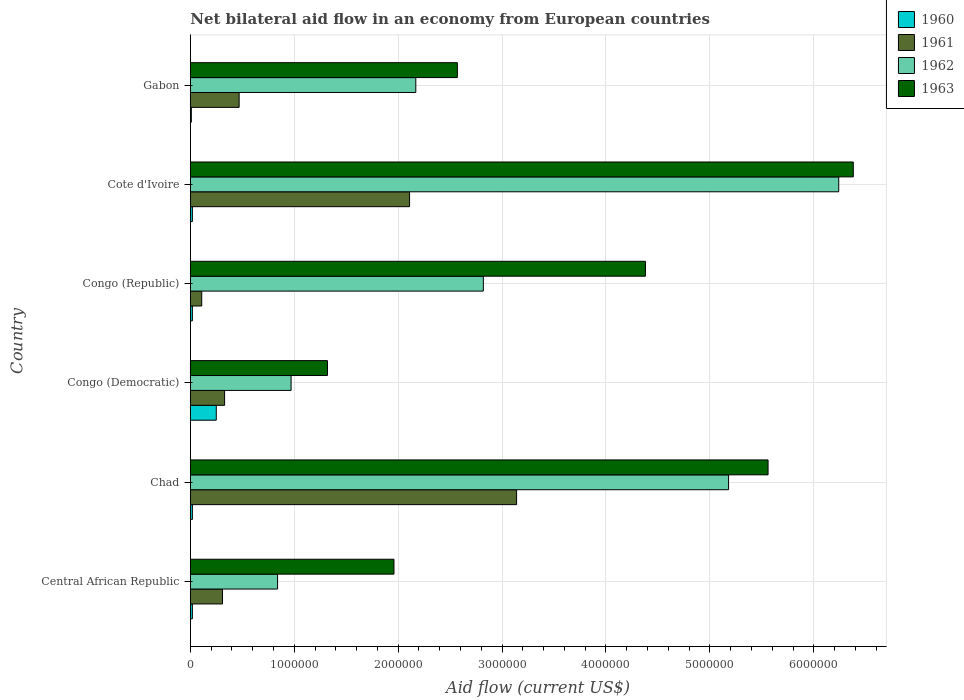How many bars are there on the 4th tick from the top?
Provide a succinct answer. 4. What is the label of the 1st group of bars from the top?
Provide a succinct answer. Gabon. In how many cases, is the number of bars for a given country not equal to the number of legend labels?
Keep it short and to the point. 0. What is the net bilateral aid flow in 1961 in Chad?
Your response must be concise. 3.14e+06. Across all countries, what is the maximum net bilateral aid flow in 1963?
Offer a terse response. 6.38e+06. Across all countries, what is the minimum net bilateral aid flow in 1963?
Provide a short and direct response. 1.32e+06. In which country was the net bilateral aid flow in 1960 maximum?
Your answer should be very brief. Congo (Democratic). In which country was the net bilateral aid flow in 1963 minimum?
Offer a terse response. Congo (Democratic). What is the total net bilateral aid flow in 1962 in the graph?
Provide a succinct answer. 1.82e+07. What is the difference between the net bilateral aid flow in 1961 in Chad and that in Congo (Republic)?
Offer a very short reply. 3.03e+06. What is the difference between the net bilateral aid flow in 1963 in Gabon and the net bilateral aid flow in 1960 in Cote d'Ivoire?
Your response must be concise. 2.55e+06. What is the average net bilateral aid flow in 1963 per country?
Offer a very short reply. 3.70e+06. What is the difference between the net bilateral aid flow in 1960 and net bilateral aid flow in 1962 in Cote d'Ivoire?
Give a very brief answer. -6.22e+06. In how many countries, is the net bilateral aid flow in 1961 greater than 200000 US$?
Your answer should be very brief. 5. What is the ratio of the net bilateral aid flow in 1963 in Central African Republic to that in Chad?
Offer a very short reply. 0.35. What is the difference between the highest and the second highest net bilateral aid flow in 1960?
Offer a very short reply. 2.30e+05. In how many countries, is the net bilateral aid flow in 1962 greater than the average net bilateral aid flow in 1962 taken over all countries?
Offer a very short reply. 2. Is the sum of the net bilateral aid flow in 1963 in Chad and Congo (Republic) greater than the maximum net bilateral aid flow in 1962 across all countries?
Offer a terse response. Yes. What does the 2nd bar from the top in Chad represents?
Keep it short and to the point. 1962. Is it the case that in every country, the sum of the net bilateral aid flow in 1963 and net bilateral aid flow in 1960 is greater than the net bilateral aid flow in 1961?
Offer a terse response. Yes. How many bars are there?
Keep it short and to the point. 24. Are all the bars in the graph horizontal?
Provide a succinct answer. Yes. How many countries are there in the graph?
Keep it short and to the point. 6. What is the difference between two consecutive major ticks on the X-axis?
Keep it short and to the point. 1.00e+06. Are the values on the major ticks of X-axis written in scientific E-notation?
Offer a very short reply. No. Where does the legend appear in the graph?
Make the answer very short. Top right. What is the title of the graph?
Your answer should be compact. Net bilateral aid flow in an economy from European countries. What is the label or title of the Y-axis?
Offer a terse response. Country. What is the Aid flow (current US$) of 1960 in Central African Republic?
Keep it short and to the point. 2.00e+04. What is the Aid flow (current US$) in 1961 in Central African Republic?
Provide a succinct answer. 3.10e+05. What is the Aid flow (current US$) of 1962 in Central African Republic?
Your answer should be very brief. 8.40e+05. What is the Aid flow (current US$) of 1963 in Central African Republic?
Make the answer very short. 1.96e+06. What is the Aid flow (current US$) in 1961 in Chad?
Your answer should be compact. 3.14e+06. What is the Aid flow (current US$) of 1962 in Chad?
Provide a succinct answer. 5.18e+06. What is the Aid flow (current US$) of 1963 in Chad?
Give a very brief answer. 5.56e+06. What is the Aid flow (current US$) in 1961 in Congo (Democratic)?
Give a very brief answer. 3.30e+05. What is the Aid flow (current US$) of 1962 in Congo (Democratic)?
Give a very brief answer. 9.70e+05. What is the Aid flow (current US$) of 1963 in Congo (Democratic)?
Provide a short and direct response. 1.32e+06. What is the Aid flow (current US$) in 1961 in Congo (Republic)?
Offer a terse response. 1.10e+05. What is the Aid flow (current US$) of 1962 in Congo (Republic)?
Provide a short and direct response. 2.82e+06. What is the Aid flow (current US$) of 1963 in Congo (Republic)?
Provide a succinct answer. 4.38e+06. What is the Aid flow (current US$) in 1961 in Cote d'Ivoire?
Provide a short and direct response. 2.11e+06. What is the Aid flow (current US$) of 1962 in Cote d'Ivoire?
Give a very brief answer. 6.24e+06. What is the Aid flow (current US$) of 1963 in Cote d'Ivoire?
Keep it short and to the point. 6.38e+06. What is the Aid flow (current US$) in 1960 in Gabon?
Your answer should be very brief. 10000. What is the Aid flow (current US$) of 1961 in Gabon?
Offer a terse response. 4.70e+05. What is the Aid flow (current US$) of 1962 in Gabon?
Offer a very short reply. 2.17e+06. What is the Aid flow (current US$) of 1963 in Gabon?
Offer a very short reply. 2.57e+06. Across all countries, what is the maximum Aid flow (current US$) in 1961?
Your answer should be very brief. 3.14e+06. Across all countries, what is the maximum Aid flow (current US$) in 1962?
Your response must be concise. 6.24e+06. Across all countries, what is the maximum Aid flow (current US$) of 1963?
Ensure brevity in your answer.  6.38e+06. Across all countries, what is the minimum Aid flow (current US$) of 1962?
Keep it short and to the point. 8.40e+05. Across all countries, what is the minimum Aid flow (current US$) in 1963?
Offer a terse response. 1.32e+06. What is the total Aid flow (current US$) in 1960 in the graph?
Give a very brief answer. 3.40e+05. What is the total Aid flow (current US$) of 1961 in the graph?
Your answer should be compact. 6.47e+06. What is the total Aid flow (current US$) of 1962 in the graph?
Make the answer very short. 1.82e+07. What is the total Aid flow (current US$) in 1963 in the graph?
Keep it short and to the point. 2.22e+07. What is the difference between the Aid flow (current US$) of 1961 in Central African Republic and that in Chad?
Offer a terse response. -2.83e+06. What is the difference between the Aid flow (current US$) in 1962 in Central African Republic and that in Chad?
Offer a very short reply. -4.34e+06. What is the difference between the Aid flow (current US$) in 1963 in Central African Republic and that in Chad?
Your answer should be very brief. -3.60e+06. What is the difference between the Aid flow (current US$) in 1960 in Central African Republic and that in Congo (Democratic)?
Provide a succinct answer. -2.30e+05. What is the difference between the Aid flow (current US$) in 1961 in Central African Republic and that in Congo (Democratic)?
Offer a very short reply. -2.00e+04. What is the difference between the Aid flow (current US$) of 1962 in Central African Republic and that in Congo (Democratic)?
Provide a short and direct response. -1.30e+05. What is the difference between the Aid flow (current US$) of 1963 in Central African Republic and that in Congo (Democratic)?
Give a very brief answer. 6.40e+05. What is the difference between the Aid flow (current US$) in 1960 in Central African Republic and that in Congo (Republic)?
Your answer should be compact. 0. What is the difference between the Aid flow (current US$) of 1961 in Central African Republic and that in Congo (Republic)?
Your answer should be very brief. 2.00e+05. What is the difference between the Aid flow (current US$) of 1962 in Central African Republic and that in Congo (Republic)?
Provide a short and direct response. -1.98e+06. What is the difference between the Aid flow (current US$) of 1963 in Central African Republic and that in Congo (Republic)?
Offer a terse response. -2.42e+06. What is the difference between the Aid flow (current US$) of 1960 in Central African Republic and that in Cote d'Ivoire?
Give a very brief answer. 0. What is the difference between the Aid flow (current US$) of 1961 in Central African Republic and that in Cote d'Ivoire?
Your answer should be compact. -1.80e+06. What is the difference between the Aid flow (current US$) in 1962 in Central African Republic and that in Cote d'Ivoire?
Keep it short and to the point. -5.40e+06. What is the difference between the Aid flow (current US$) of 1963 in Central African Republic and that in Cote d'Ivoire?
Your answer should be very brief. -4.42e+06. What is the difference between the Aid flow (current US$) of 1960 in Central African Republic and that in Gabon?
Provide a short and direct response. 10000. What is the difference between the Aid flow (current US$) in 1962 in Central African Republic and that in Gabon?
Offer a very short reply. -1.33e+06. What is the difference between the Aid flow (current US$) of 1963 in Central African Republic and that in Gabon?
Make the answer very short. -6.10e+05. What is the difference between the Aid flow (current US$) of 1960 in Chad and that in Congo (Democratic)?
Give a very brief answer. -2.30e+05. What is the difference between the Aid flow (current US$) in 1961 in Chad and that in Congo (Democratic)?
Make the answer very short. 2.81e+06. What is the difference between the Aid flow (current US$) in 1962 in Chad and that in Congo (Democratic)?
Ensure brevity in your answer.  4.21e+06. What is the difference between the Aid flow (current US$) of 1963 in Chad and that in Congo (Democratic)?
Your response must be concise. 4.24e+06. What is the difference between the Aid flow (current US$) of 1961 in Chad and that in Congo (Republic)?
Keep it short and to the point. 3.03e+06. What is the difference between the Aid flow (current US$) in 1962 in Chad and that in Congo (Republic)?
Your answer should be very brief. 2.36e+06. What is the difference between the Aid flow (current US$) of 1963 in Chad and that in Congo (Republic)?
Your answer should be very brief. 1.18e+06. What is the difference between the Aid flow (current US$) in 1961 in Chad and that in Cote d'Ivoire?
Keep it short and to the point. 1.03e+06. What is the difference between the Aid flow (current US$) of 1962 in Chad and that in Cote d'Ivoire?
Your response must be concise. -1.06e+06. What is the difference between the Aid flow (current US$) in 1963 in Chad and that in Cote d'Ivoire?
Give a very brief answer. -8.20e+05. What is the difference between the Aid flow (current US$) of 1961 in Chad and that in Gabon?
Offer a very short reply. 2.67e+06. What is the difference between the Aid flow (current US$) in 1962 in Chad and that in Gabon?
Your answer should be compact. 3.01e+06. What is the difference between the Aid flow (current US$) in 1963 in Chad and that in Gabon?
Ensure brevity in your answer.  2.99e+06. What is the difference between the Aid flow (current US$) in 1960 in Congo (Democratic) and that in Congo (Republic)?
Offer a terse response. 2.30e+05. What is the difference between the Aid flow (current US$) of 1962 in Congo (Democratic) and that in Congo (Republic)?
Keep it short and to the point. -1.85e+06. What is the difference between the Aid flow (current US$) of 1963 in Congo (Democratic) and that in Congo (Republic)?
Provide a short and direct response. -3.06e+06. What is the difference between the Aid flow (current US$) in 1961 in Congo (Democratic) and that in Cote d'Ivoire?
Make the answer very short. -1.78e+06. What is the difference between the Aid flow (current US$) in 1962 in Congo (Democratic) and that in Cote d'Ivoire?
Offer a terse response. -5.27e+06. What is the difference between the Aid flow (current US$) in 1963 in Congo (Democratic) and that in Cote d'Ivoire?
Provide a short and direct response. -5.06e+06. What is the difference between the Aid flow (current US$) of 1960 in Congo (Democratic) and that in Gabon?
Give a very brief answer. 2.40e+05. What is the difference between the Aid flow (current US$) in 1961 in Congo (Democratic) and that in Gabon?
Keep it short and to the point. -1.40e+05. What is the difference between the Aid flow (current US$) in 1962 in Congo (Democratic) and that in Gabon?
Provide a succinct answer. -1.20e+06. What is the difference between the Aid flow (current US$) of 1963 in Congo (Democratic) and that in Gabon?
Give a very brief answer. -1.25e+06. What is the difference between the Aid flow (current US$) in 1960 in Congo (Republic) and that in Cote d'Ivoire?
Your answer should be very brief. 0. What is the difference between the Aid flow (current US$) in 1962 in Congo (Republic) and that in Cote d'Ivoire?
Your answer should be very brief. -3.42e+06. What is the difference between the Aid flow (current US$) of 1963 in Congo (Republic) and that in Cote d'Ivoire?
Offer a terse response. -2.00e+06. What is the difference between the Aid flow (current US$) in 1960 in Congo (Republic) and that in Gabon?
Your answer should be very brief. 10000. What is the difference between the Aid flow (current US$) in 1961 in Congo (Republic) and that in Gabon?
Ensure brevity in your answer.  -3.60e+05. What is the difference between the Aid flow (current US$) in 1962 in Congo (Republic) and that in Gabon?
Keep it short and to the point. 6.50e+05. What is the difference between the Aid flow (current US$) of 1963 in Congo (Republic) and that in Gabon?
Your answer should be very brief. 1.81e+06. What is the difference between the Aid flow (current US$) in 1961 in Cote d'Ivoire and that in Gabon?
Offer a very short reply. 1.64e+06. What is the difference between the Aid flow (current US$) in 1962 in Cote d'Ivoire and that in Gabon?
Provide a short and direct response. 4.07e+06. What is the difference between the Aid flow (current US$) of 1963 in Cote d'Ivoire and that in Gabon?
Give a very brief answer. 3.81e+06. What is the difference between the Aid flow (current US$) in 1960 in Central African Republic and the Aid flow (current US$) in 1961 in Chad?
Make the answer very short. -3.12e+06. What is the difference between the Aid flow (current US$) in 1960 in Central African Republic and the Aid flow (current US$) in 1962 in Chad?
Give a very brief answer. -5.16e+06. What is the difference between the Aid flow (current US$) in 1960 in Central African Republic and the Aid flow (current US$) in 1963 in Chad?
Keep it short and to the point. -5.54e+06. What is the difference between the Aid flow (current US$) of 1961 in Central African Republic and the Aid flow (current US$) of 1962 in Chad?
Provide a succinct answer. -4.87e+06. What is the difference between the Aid flow (current US$) in 1961 in Central African Republic and the Aid flow (current US$) in 1963 in Chad?
Keep it short and to the point. -5.25e+06. What is the difference between the Aid flow (current US$) in 1962 in Central African Republic and the Aid flow (current US$) in 1963 in Chad?
Ensure brevity in your answer.  -4.72e+06. What is the difference between the Aid flow (current US$) of 1960 in Central African Republic and the Aid flow (current US$) of 1961 in Congo (Democratic)?
Your answer should be very brief. -3.10e+05. What is the difference between the Aid flow (current US$) in 1960 in Central African Republic and the Aid flow (current US$) in 1962 in Congo (Democratic)?
Your answer should be compact. -9.50e+05. What is the difference between the Aid flow (current US$) in 1960 in Central African Republic and the Aid flow (current US$) in 1963 in Congo (Democratic)?
Offer a terse response. -1.30e+06. What is the difference between the Aid flow (current US$) in 1961 in Central African Republic and the Aid flow (current US$) in 1962 in Congo (Democratic)?
Keep it short and to the point. -6.60e+05. What is the difference between the Aid flow (current US$) of 1961 in Central African Republic and the Aid flow (current US$) of 1963 in Congo (Democratic)?
Make the answer very short. -1.01e+06. What is the difference between the Aid flow (current US$) in 1962 in Central African Republic and the Aid flow (current US$) in 1963 in Congo (Democratic)?
Your answer should be very brief. -4.80e+05. What is the difference between the Aid flow (current US$) in 1960 in Central African Republic and the Aid flow (current US$) in 1961 in Congo (Republic)?
Offer a very short reply. -9.00e+04. What is the difference between the Aid flow (current US$) of 1960 in Central African Republic and the Aid flow (current US$) of 1962 in Congo (Republic)?
Your response must be concise. -2.80e+06. What is the difference between the Aid flow (current US$) of 1960 in Central African Republic and the Aid flow (current US$) of 1963 in Congo (Republic)?
Your response must be concise. -4.36e+06. What is the difference between the Aid flow (current US$) of 1961 in Central African Republic and the Aid flow (current US$) of 1962 in Congo (Republic)?
Ensure brevity in your answer.  -2.51e+06. What is the difference between the Aid flow (current US$) in 1961 in Central African Republic and the Aid flow (current US$) in 1963 in Congo (Republic)?
Provide a succinct answer. -4.07e+06. What is the difference between the Aid flow (current US$) of 1962 in Central African Republic and the Aid flow (current US$) of 1963 in Congo (Republic)?
Give a very brief answer. -3.54e+06. What is the difference between the Aid flow (current US$) in 1960 in Central African Republic and the Aid flow (current US$) in 1961 in Cote d'Ivoire?
Your answer should be compact. -2.09e+06. What is the difference between the Aid flow (current US$) of 1960 in Central African Republic and the Aid flow (current US$) of 1962 in Cote d'Ivoire?
Your answer should be compact. -6.22e+06. What is the difference between the Aid flow (current US$) in 1960 in Central African Republic and the Aid flow (current US$) in 1963 in Cote d'Ivoire?
Offer a terse response. -6.36e+06. What is the difference between the Aid flow (current US$) of 1961 in Central African Republic and the Aid flow (current US$) of 1962 in Cote d'Ivoire?
Your response must be concise. -5.93e+06. What is the difference between the Aid flow (current US$) in 1961 in Central African Republic and the Aid flow (current US$) in 1963 in Cote d'Ivoire?
Offer a very short reply. -6.07e+06. What is the difference between the Aid flow (current US$) in 1962 in Central African Republic and the Aid flow (current US$) in 1963 in Cote d'Ivoire?
Ensure brevity in your answer.  -5.54e+06. What is the difference between the Aid flow (current US$) of 1960 in Central African Republic and the Aid flow (current US$) of 1961 in Gabon?
Offer a terse response. -4.50e+05. What is the difference between the Aid flow (current US$) in 1960 in Central African Republic and the Aid flow (current US$) in 1962 in Gabon?
Make the answer very short. -2.15e+06. What is the difference between the Aid flow (current US$) in 1960 in Central African Republic and the Aid flow (current US$) in 1963 in Gabon?
Your response must be concise. -2.55e+06. What is the difference between the Aid flow (current US$) in 1961 in Central African Republic and the Aid flow (current US$) in 1962 in Gabon?
Ensure brevity in your answer.  -1.86e+06. What is the difference between the Aid flow (current US$) in 1961 in Central African Republic and the Aid flow (current US$) in 1963 in Gabon?
Offer a very short reply. -2.26e+06. What is the difference between the Aid flow (current US$) of 1962 in Central African Republic and the Aid flow (current US$) of 1963 in Gabon?
Ensure brevity in your answer.  -1.73e+06. What is the difference between the Aid flow (current US$) in 1960 in Chad and the Aid flow (current US$) in 1961 in Congo (Democratic)?
Give a very brief answer. -3.10e+05. What is the difference between the Aid flow (current US$) in 1960 in Chad and the Aid flow (current US$) in 1962 in Congo (Democratic)?
Offer a terse response. -9.50e+05. What is the difference between the Aid flow (current US$) in 1960 in Chad and the Aid flow (current US$) in 1963 in Congo (Democratic)?
Your answer should be very brief. -1.30e+06. What is the difference between the Aid flow (current US$) of 1961 in Chad and the Aid flow (current US$) of 1962 in Congo (Democratic)?
Your response must be concise. 2.17e+06. What is the difference between the Aid flow (current US$) in 1961 in Chad and the Aid flow (current US$) in 1963 in Congo (Democratic)?
Offer a terse response. 1.82e+06. What is the difference between the Aid flow (current US$) in 1962 in Chad and the Aid flow (current US$) in 1963 in Congo (Democratic)?
Give a very brief answer. 3.86e+06. What is the difference between the Aid flow (current US$) of 1960 in Chad and the Aid flow (current US$) of 1961 in Congo (Republic)?
Offer a terse response. -9.00e+04. What is the difference between the Aid flow (current US$) of 1960 in Chad and the Aid flow (current US$) of 1962 in Congo (Republic)?
Your answer should be very brief. -2.80e+06. What is the difference between the Aid flow (current US$) of 1960 in Chad and the Aid flow (current US$) of 1963 in Congo (Republic)?
Ensure brevity in your answer.  -4.36e+06. What is the difference between the Aid flow (current US$) of 1961 in Chad and the Aid flow (current US$) of 1962 in Congo (Republic)?
Your answer should be very brief. 3.20e+05. What is the difference between the Aid flow (current US$) in 1961 in Chad and the Aid flow (current US$) in 1963 in Congo (Republic)?
Provide a succinct answer. -1.24e+06. What is the difference between the Aid flow (current US$) of 1962 in Chad and the Aid flow (current US$) of 1963 in Congo (Republic)?
Offer a terse response. 8.00e+05. What is the difference between the Aid flow (current US$) in 1960 in Chad and the Aid flow (current US$) in 1961 in Cote d'Ivoire?
Your response must be concise. -2.09e+06. What is the difference between the Aid flow (current US$) in 1960 in Chad and the Aid flow (current US$) in 1962 in Cote d'Ivoire?
Ensure brevity in your answer.  -6.22e+06. What is the difference between the Aid flow (current US$) of 1960 in Chad and the Aid flow (current US$) of 1963 in Cote d'Ivoire?
Ensure brevity in your answer.  -6.36e+06. What is the difference between the Aid flow (current US$) in 1961 in Chad and the Aid flow (current US$) in 1962 in Cote d'Ivoire?
Offer a terse response. -3.10e+06. What is the difference between the Aid flow (current US$) in 1961 in Chad and the Aid flow (current US$) in 1963 in Cote d'Ivoire?
Your answer should be compact. -3.24e+06. What is the difference between the Aid flow (current US$) of 1962 in Chad and the Aid flow (current US$) of 1963 in Cote d'Ivoire?
Ensure brevity in your answer.  -1.20e+06. What is the difference between the Aid flow (current US$) in 1960 in Chad and the Aid flow (current US$) in 1961 in Gabon?
Your response must be concise. -4.50e+05. What is the difference between the Aid flow (current US$) in 1960 in Chad and the Aid flow (current US$) in 1962 in Gabon?
Keep it short and to the point. -2.15e+06. What is the difference between the Aid flow (current US$) of 1960 in Chad and the Aid flow (current US$) of 1963 in Gabon?
Provide a short and direct response. -2.55e+06. What is the difference between the Aid flow (current US$) of 1961 in Chad and the Aid flow (current US$) of 1962 in Gabon?
Keep it short and to the point. 9.70e+05. What is the difference between the Aid flow (current US$) in 1961 in Chad and the Aid flow (current US$) in 1963 in Gabon?
Offer a terse response. 5.70e+05. What is the difference between the Aid flow (current US$) of 1962 in Chad and the Aid flow (current US$) of 1963 in Gabon?
Keep it short and to the point. 2.61e+06. What is the difference between the Aid flow (current US$) of 1960 in Congo (Democratic) and the Aid flow (current US$) of 1962 in Congo (Republic)?
Provide a succinct answer. -2.57e+06. What is the difference between the Aid flow (current US$) of 1960 in Congo (Democratic) and the Aid flow (current US$) of 1963 in Congo (Republic)?
Keep it short and to the point. -4.13e+06. What is the difference between the Aid flow (current US$) of 1961 in Congo (Democratic) and the Aid flow (current US$) of 1962 in Congo (Republic)?
Ensure brevity in your answer.  -2.49e+06. What is the difference between the Aid flow (current US$) in 1961 in Congo (Democratic) and the Aid flow (current US$) in 1963 in Congo (Republic)?
Ensure brevity in your answer.  -4.05e+06. What is the difference between the Aid flow (current US$) in 1962 in Congo (Democratic) and the Aid flow (current US$) in 1963 in Congo (Republic)?
Provide a succinct answer. -3.41e+06. What is the difference between the Aid flow (current US$) of 1960 in Congo (Democratic) and the Aid flow (current US$) of 1961 in Cote d'Ivoire?
Offer a terse response. -1.86e+06. What is the difference between the Aid flow (current US$) in 1960 in Congo (Democratic) and the Aid flow (current US$) in 1962 in Cote d'Ivoire?
Your answer should be very brief. -5.99e+06. What is the difference between the Aid flow (current US$) of 1960 in Congo (Democratic) and the Aid flow (current US$) of 1963 in Cote d'Ivoire?
Offer a terse response. -6.13e+06. What is the difference between the Aid flow (current US$) in 1961 in Congo (Democratic) and the Aid flow (current US$) in 1962 in Cote d'Ivoire?
Your answer should be compact. -5.91e+06. What is the difference between the Aid flow (current US$) of 1961 in Congo (Democratic) and the Aid flow (current US$) of 1963 in Cote d'Ivoire?
Provide a succinct answer. -6.05e+06. What is the difference between the Aid flow (current US$) in 1962 in Congo (Democratic) and the Aid flow (current US$) in 1963 in Cote d'Ivoire?
Provide a succinct answer. -5.41e+06. What is the difference between the Aid flow (current US$) in 1960 in Congo (Democratic) and the Aid flow (current US$) in 1962 in Gabon?
Give a very brief answer. -1.92e+06. What is the difference between the Aid flow (current US$) in 1960 in Congo (Democratic) and the Aid flow (current US$) in 1963 in Gabon?
Your answer should be compact. -2.32e+06. What is the difference between the Aid flow (current US$) in 1961 in Congo (Democratic) and the Aid flow (current US$) in 1962 in Gabon?
Make the answer very short. -1.84e+06. What is the difference between the Aid flow (current US$) in 1961 in Congo (Democratic) and the Aid flow (current US$) in 1963 in Gabon?
Your answer should be compact. -2.24e+06. What is the difference between the Aid flow (current US$) of 1962 in Congo (Democratic) and the Aid flow (current US$) of 1963 in Gabon?
Make the answer very short. -1.60e+06. What is the difference between the Aid flow (current US$) of 1960 in Congo (Republic) and the Aid flow (current US$) of 1961 in Cote d'Ivoire?
Offer a very short reply. -2.09e+06. What is the difference between the Aid flow (current US$) in 1960 in Congo (Republic) and the Aid flow (current US$) in 1962 in Cote d'Ivoire?
Your response must be concise. -6.22e+06. What is the difference between the Aid flow (current US$) of 1960 in Congo (Republic) and the Aid flow (current US$) of 1963 in Cote d'Ivoire?
Offer a very short reply. -6.36e+06. What is the difference between the Aid flow (current US$) of 1961 in Congo (Republic) and the Aid flow (current US$) of 1962 in Cote d'Ivoire?
Keep it short and to the point. -6.13e+06. What is the difference between the Aid flow (current US$) of 1961 in Congo (Republic) and the Aid flow (current US$) of 1963 in Cote d'Ivoire?
Offer a very short reply. -6.27e+06. What is the difference between the Aid flow (current US$) in 1962 in Congo (Republic) and the Aid flow (current US$) in 1963 in Cote d'Ivoire?
Ensure brevity in your answer.  -3.56e+06. What is the difference between the Aid flow (current US$) of 1960 in Congo (Republic) and the Aid flow (current US$) of 1961 in Gabon?
Make the answer very short. -4.50e+05. What is the difference between the Aid flow (current US$) of 1960 in Congo (Republic) and the Aid flow (current US$) of 1962 in Gabon?
Provide a succinct answer. -2.15e+06. What is the difference between the Aid flow (current US$) of 1960 in Congo (Republic) and the Aid flow (current US$) of 1963 in Gabon?
Offer a very short reply. -2.55e+06. What is the difference between the Aid flow (current US$) of 1961 in Congo (Republic) and the Aid flow (current US$) of 1962 in Gabon?
Your response must be concise. -2.06e+06. What is the difference between the Aid flow (current US$) of 1961 in Congo (Republic) and the Aid flow (current US$) of 1963 in Gabon?
Offer a terse response. -2.46e+06. What is the difference between the Aid flow (current US$) in 1960 in Cote d'Ivoire and the Aid flow (current US$) in 1961 in Gabon?
Offer a very short reply. -4.50e+05. What is the difference between the Aid flow (current US$) in 1960 in Cote d'Ivoire and the Aid flow (current US$) in 1962 in Gabon?
Provide a short and direct response. -2.15e+06. What is the difference between the Aid flow (current US$) of 1960 in Cote d'Ivoire and the Aid flow (current US$) of 1963 in Gabon?
Make the answer very short. -2.55e+06. What is the difference between the Aid flow (current US$) in 1961 in Cote d'Ivoire and the Aid flow (current US$) in 1962 in Gabon?
Keep it short and to the point. -6.00e+04. What is the difference between the Aid flow (current US$) of 1961 in Cote d'Ivoire and the Aid flow (current US$) of 1963 in Gabon?
Offer a terse response. -4.60e+05. What is the difference between the Aid flow (current US$) in 1962 in Cote d'Ivoire and the Aid flow (current US$) in 1963 in Gabon?
Ensure brevity in your answer.  3.67e+06. What is the average Aid flow (current US$) of 1960 per country?
Offer a terse response. 5.67e+04. What is the average Aid flow (current US$) in 1961 per country?
Offer a terse response. 1.08e+06. What is the average Aid flow (current US$) of 1962 per country?
Ensure brevity in your answer.  3.04e+06. What is the average Aid flow (current US$) in 1963 per country?
Make the answer very short. 3.70e+06. What is the difference between the Aid flow (current US$) in 1960 and Aid flow (current US$) in 1962 in Central African Republic?
Provide a short and direct response. -8.20e+05. What is the difference between the Aid flow (current US$) of 1960 and Aid flow (current US$) of 1963 in Central African Republic?
Provide a succinct answer. -1.94e+06. What is the difference between the Aid flow (current US$) in 1961 and Aid flow (current US$) in 1962 in Central African Republic?
Your answer should be compact. -5.30e+05. What is the difference between the Aid flow (current US$) in 1961 and Aid flow (current US$) in 1963 in Central African Republic?
Provide a succinct answer. -1.65e+06. What is the difference between the Aid flow (current US$) in 1962 and Aid flow (current US$) in 1963 in Central African Republic?
Make the answer very short. -1.12e+06. What is the difference between the Aid flow (current US$) of 1960 and Aid flow (current US$) of 1961 in Chad?
Offer a very short reply. -3.12e+06. What is the difference between the Aid flow (current US$) of 1960 and Aid flow (current US$) of 1962 in Chad?
Your response must be concise. -5.16e+06. What is the difference between the Aid flow (current US$) of 1960 and Aid flow (current US$) of 1963 in Chad?
Provide a succinct answer. -5.54e+06. What is the difference between the Aid flow (current US$) in 1961 and Aid flow (current US$) in 1962 in Chad?
Your response must be concise. -2.04e+06. What is the difference between the Aid flow (current US$) of 1961 and Aid flow (current US$) of 1963 in Chad?
Keep it short and to the point. -2.42e+06. What is the difference between the Aid flow (current US$) of 1962 and Aid flow (current US$) of 1963 in Chad?
Make the answer very short. -3.80e+05. What is the difference between the Aid flow (current US$) in 1960 and Aid flow (current US$) in 1962 in Congo (Democratic)?
Ensure brevity in your answer.  -7.20e+05. What is the difference between the Aid flow (current US$) in 1960 and Aid flow (current US$) in 1963 in Congo (Democratic)?
Keep it short and to the point. -1.07e+06. What is the difference between the Aid flow (current US$) in 1961 and Aid flow (current US$) in 1962 in Congo (Democratic)?
Offer a very short reply. -6.40e+05. What is the difference between the Aid flow (current US$) in 1961 and Aid flow (current US$) in 1963 in Congo (Democratic)?
Offer a terse response. -9.90e+05. What is the difference between the Aid flow (current US$) of 1962 and Aid flow (current US$) of 1963 in Congo (Democratic)?
Make the answer very short. -3.50e+05. What is the difference between the Aid flow (current US$) in 1960 and Aid flow (current US$) in 1961 in Congo (Republic)?
Offer a terse response. -9.00e+04. What is the difference between the Aid flow (current US$) in 1960 and Aid flow (current US$) in 1962 in Congo (Republic)?
Offer a very short reply. -2.80e+06. What is the difference between the Aid flow (current US$) in 1960 and Aid flow (current US$) in 1963 in Congo (Republic)?
Provide a succinct answer. -4.36e+06. What is the difference between the Aid flow (current US$) of 1961 and Aid flow (current US$) of 1962 in Congo (Republic)?
Ensure brevity in your answer.  -2.71e+06. What is the difference between the Aid flow (current US$) in 1961 and Aid flow (current US$) in 1963 in Congo (Republic)?
Ensure brevity in your answer.  -4.27e+06. What is the difference between the Aid flow (current US$) of 1962 and Aid flow (current US$) of 1963 in Congo (Republic)?
Offer a terse response. -1.56e+06. What is the difference between the Aid flow (current US$) of 1960 and Aid flow (current US$) of 1961 in Cote d'Ivoire?
Give a very brief answer. -2.09e+06. What is the difference between the Aid flow (current US$) in 1960 and Aid flow (current US$) in 1962 in Cote d'Ivoire?
Make the answer very short. -6.22e+06. What is the difference between the Aid flow (current US$) in 1960 and Aid flow (current US$) in 1963 in Cote d'Ivoire?
Ensure brevity in your answer.  -6.36e+06. What is the difference between the Aid flow (current US$) in 1961 and Aid flow (current US$) in 1962 in Cote d'Ivoire?
Provide a succinct answer. -4.13e+06. What is the difference between the Aid flow (current US$) in 1961 and Aid flow (current US$) in 1963 in Cote d'Ivoire?
Make the answer very short. -4.27e+06. What is the difference between the Aid flow (current US$) in 1960 and Aid flow (current US$) in 1961 in Gabon?
Provide a succinct answer. -4.60e+05. What is the difference between the Aid flow (current US$) in 1960 and Aid flow (current US$) in 1962 in Gabon?
Ensure brevity in your answer.  -2.16e+06. What is the difference between the Aid flow (current US$) of 1960 and Aid flow (current US$) of 1963 in Gabon?
Keep it short and to the point. -2.56e+06. What is the difference between the Aid flow (current US$) of 1961 and Aid flow (current US$) of 1962 in Gabon?
Your answer should be very brief. -1.70e+06. What is the difference between the Aid flow (current US$) in 1961 and Aid flow (current US$) in 1963 in Gabon?
Make the answer very short. -2.10e+06. What is the difference between the Aid flow (current US$) of 1962 and Aid flow (current US$) of 1963 in Gabon?
Make the answer very short. -4.00e+05. What is the ratio of the Aid flow (current US$) of 1960 in Central African Republic to that in Chad?
Your answer should be compact. 1. What is the ratio of the Aid flow (current US$) of 1961 in Central African Republic to that in Chad?
Offer a very short reply. 0.1. What is the ratio of the Aid flow (current US$) in 1962 in Central African Republic to that in Chad?
Your response must be concise. 0.16. What is the ratio of the Aid flow (current US$) in 1963 in Central African Republic to that in Chad?
Ensure brevity in your answer.  0.35. What is the ratio of the Aid flow (current US$) in 1960 in Central African Republic to that in Congo (Democratic)?
Your response must be concise. 0.08. What is the ratio of the Aid flow (current US$) of 1961 in Central African Republic to that in Congo (Democratic)?
Provide a succinct answer. 0.94. What is the ratio of the Aid flow (current US$) in 1962 in Central African Republic to that in Congo (Democratic)?
Offer a terse response. 0.87. What is the ratio of the Aid flow (current US$) of 1963 in Central African Republic to that in Congo (Democratic)?
Offer a very short reply. 1.48. What is the ratio of the Aid flow (current US$) in 1961 in Central African Republic to that in Congo (Republic)?
Your answer should be compact. 2.82. What is the ratio of the Aid flow (current US$) in 1962 in Central African Republic to that in Congo (Republic)?
Offer a terse response. 0.3. What is the ratio of the Aid flow (current US$) in 1963 in Central African Republic to that in Congo (Republic)?
Give a very brief answer. 0.45. What is the ratio of the Aid flow (current US$) of 1960 in Central African Republic to that in Cote d'Ivoire?
Your response must be concise. 1. What is the ratio of the Aid flow (current US$) in 1961 in Central African Republic to that in Cote d'Ivoire?
Offer a terse response. 0.15. What is the ratio of the Aid flow (current US$) in 1962 in Central African Republic to that in Cote d'Ivoire?
Make the answer very short. 0.13. What is the ratio of the Aid flow (current US$) in 1963 in Central African Republic to that in Cote d'Ivoire?
Offer a terse response. 0.31. What is the ratio of the Aid flow (current US$) in 1961 in Central African Republic to that in Gabon?
Your answer should be very brief. 0.66. What is the ratio of the Aid flow (current US$) in 1962 in Central African Republic to that in Gabon?
Provide a succinct answer. 0.39. What is the ratio of the Aid flow (current US$) in 1963 in Central African Republic to that in Gabon?
Give a very brief answer. 0.76. What is the ratio of the Aid flow (current US$) in 1960 in Chad to that in Congo (Democratic)?
Your response must be concise. 0.08. What is the ratio of the Aid flow (current US$) of 1961 in Chad to that in Congo (Democratic)?
Your answer should be very brief. 9.52. What is the ratio of the Aid flow (current US$) of 1962 in Chad to that in Congo (Democratic)?
Make the answer very short. 5.34. What is the ratio of the Aid flow (current US$) of 1963 in Chad to that in Congo (Democratic)?
Make the answer very short. 4.21. What is the ratio of the Aid flow (current US$) of 1960 in Chad to that in Congo (Republic)?
Provide a succinct answer. 1. What is the ratio of the Aid flow (current US$) in 1961 in Chad to that in Congo (Republic)?
Provide a short and direct response. 28.55. What is the ratio of the Aid flow (current US$) of 1962 in Chad to that in Congo (Republic)?
Offer a very short reply. 1.84. What is the ratio of the Aid flow (current US$) of 1963 in Chad to that in Congo (Republic)?
Provide a succinct answer. 1.27. What is the ratio of the Aid flow (current US$) in 1960 in Chad to that in Cote d'Ivoire?
Your response must be concise. 1. What is the ratio of the Aid flow (current US$) in 1961 in Chad to that in Cote d'Ivoire?
Your answer should be very brief. 1.49. What is the ratio of the Aid flow (current US$) in 1962 in Chad to that in Cote d'Ivoire?
Make the answer very short. 0.83. What is the ratio of the Aid flow (current US$) in 1963 in Chad to that in Cote d'Ivoire?
Your response must be concise. 0.87. What is the ratio of the Aid flow (current US$) of 1961 in Chad to that in Gabon?
Give a very brief answer. 6.68. What is the ratio of the Aid flow (current US$) of 1962 in Chad to that in Gabon?
Your response must be concise. 2.39. What is the ratio of the Aid flow (current US$) of 1963 in Chad to that in Gabon?
Offer a very short reply. 2.16. What is the ratio of the Aid flow (current US$) in 1960 in Congo (Democratic) to that in Congo (Republic)?
Provide a short and direct response. 12.5. What is the ratio of the Aid flow (current US$) of 1961 in Congo (Democratic) to that in Congo (Republic)?
Keep it short and to the point. 3. What is the ratio of the Aid flow (current US$) of 1962 in Congo (Democratic) to that in Congo (Republic)?
Your answer should be very brief. 0.34. What is the ratio of the Aid flow (current US$) of 1963 in Congo (Democratic) to that in Congo (Republic)?
Provide a succinct answer. 0.3. What is the ratio of the Aid flow (current US$) of 1961 in Congo (Democratic) to that in Cote d'Ivoire?
Offer a terse response. 0.16. What is the ratio of the Aid flow (current US$) of 1962 in Congo (Democratic) to that in Cote d'Ivoire?
Offer a terse response. 0.16. What is the ratio of the Aid flow (current US$) of 1963 in Congo (Democratic) to that in Cote d'Ivoire?
Ensure brevity in your answer.  0.21. What is the ratio of the Aid flow (current US$) in 1960 in Congo (Democratic) to that in Gabon?
Give a very brief answer. 25. What is the ratio of the Aid flow (current US$) in 1961 in Congo (Democratic) to that in Gabon?
Offer a terse response. 0.7. What is the ratio of the Aid flow (current US$) of 1962 in Congo (Democratic) to that in Gabon?
Your answer should be very brief. 0.45. What is the ratio of the Aid flow (current US$) in 1963 in Congo (Democratic) to that in Gabon?
Offer a very short reply. 0.51. What is the ratio of the Aid flow (current US$) of 1961 in Congo (Republic) to that in Cote d'Ivoire?
Offer a terse response. 0.05. What is the ratio of the Aid flow (current US$) in 1962 in Congo (Republic) to that in Cote d'Ivoire?
Make the answer very short. 0.45. What is the ratio of the Aid flow (current US$) of 1963 in Congo (Republic) to that in Cote d'Ivoire?
Keep it short and to the point. 0.69. What is the ratio of the Aid flow (current US$) of 1960 in Congo (Republic) to that in Gabon?
Keep it short and to the point. 2. What is the ratio of the Aid flow (current US$) of 1961 in Congo (Republic) to that in Gabon?
Provide a short and direct response. 0.23. What is the ratio of the Aid flow (current US$) of 1962 in Congo (Republic) to that in Gabon?
Give a very brief answer. 1.3. What is the ratio of the Aid flow (current US$) in 1963 in Congo (Republic) to that in Gabon?
Your answer should be very brief. 1.7. What is the ratio of the Aid flow (current US$) in 1960 in Cote d'Ivoire to that in Gabon?
Provide a short and direct response. 2. What is the ratio of the Aid flow (current US$) in 1961 in Cote d'Ivoire to that in Gabon?
Offer a terse response. 4.49. What is the ratio of the Aid flow (current US$) in 1962 in Cote d'Ivoire to that in Gabon?
Offer a very short reply. 2.88. What is the ratio of the Aid flow (current US$) of 1963 in Cote d'Ivoire to that in Gabon?
Keep it short and to the point. 2.48. What is the difference between the highest and the second highest Aid flow (current US$) of 1960?
Provide a succinct answer. 2.30e+05. What is the difference between the highest and the second highest Aid flow (current US$) of 1961?
Make the answer very short. 1.03e+06. What is the difference between the highest and the second highest Aid flow (current US$) in 1962?
Offer a very short reply. 1.06e+06. What is the difference between the highest and the second highest Aid flow (current US$) of 1963?
Make the answer very short. 8.20e+05. What is the difference between the highest and the lowest Aid flow (current US$) of 1961?
Make the answer very short. 3.03e+06. What is the difference between the highest and the lowest Aid flow (current US$) of 1962?
Your response must be concise. 5.40e+06. What is the difference between the highest and the lowest Aid flow (current US$) of 1963?
Your answer should be very brief. 5.06e+06. 